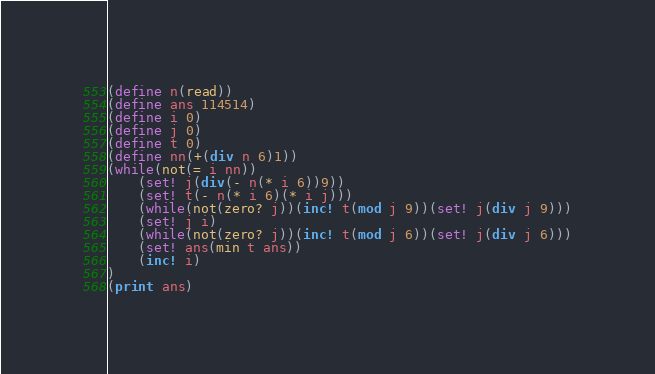<code> <loc_0><loc_0><loc_500><loc_500><_Scheme_>(define n(read))
(define ans 114514)
(define i 0)
(define j 0)
(define t 0)
(define nn(+(div n 6)1))
(while(not(= i nn))
	(set! j(div(- n(* i 6))9))
	(set! t(- n(* i 6)(* i j)))
	(while(not(zero? j))(inc! t(mod j 9))(set! j(div j 9)))
	(set! j i)
	(while(not(zero? j))(inc! t(mod j 6))(set! j(div j 6)))
	(set! ans(min t ans))
	(inc! i)
)
(print ans)</code> 